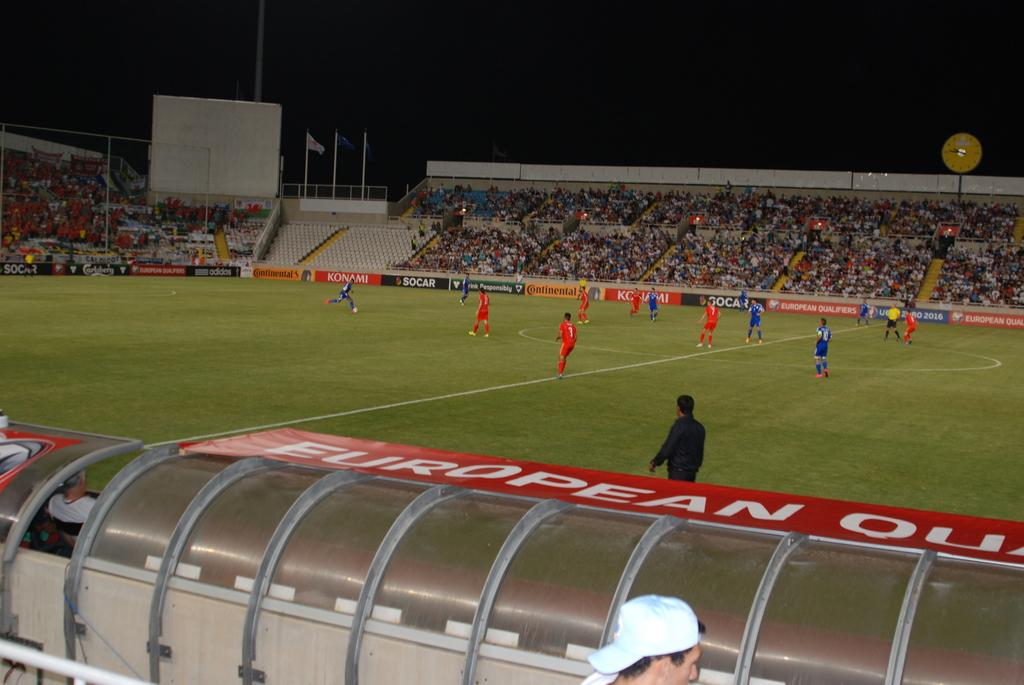<image>
Present a compact description of the photo's key features. some players on a field with the word European next to the field 